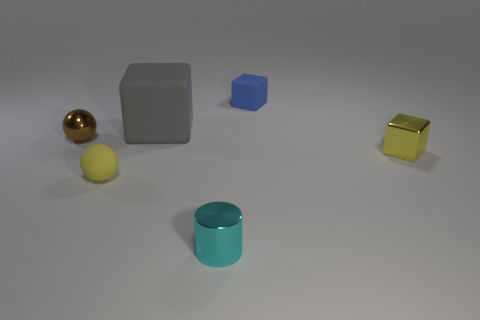Subtract all big rubber blocks. How many blocks are left? 2 Add 1 tiny matte things. How many objects exist? 7 Subtract 2 cubes. How many cubes are left? 1 Subtract all gray blocks. How many blocks are left? 2 Subtract 1 gray cubes. How many objects are left? 5 Subtract all cylinders. How many objects are left? 5 Subtract all gray blocks. Subtract all yellow spheres. How many blocks are left? 2 Subtract all cyan cylinders. How many yellow spheres are left? 1 Subtract all tiny things. Subtract all brown metal things. How many objects are left? 0 Add 4 small metal cylinders. How many small metal cylinders are left? 5 